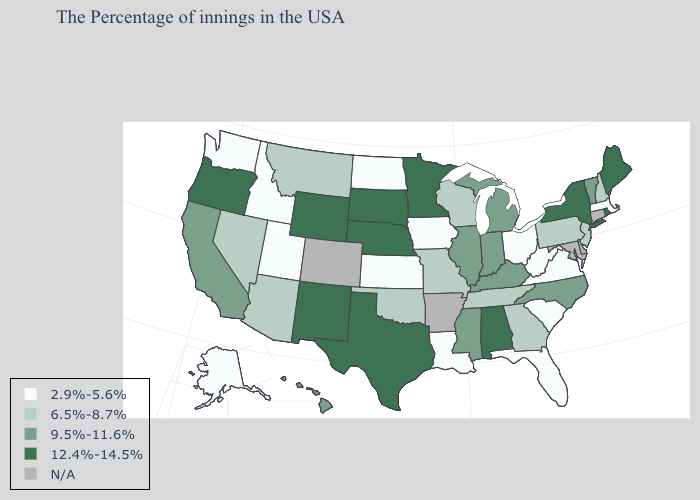Is the legend a continuous bar?
Give a very brief answer. No. Name the states that have a value in the range N/A?
Quick response, please. Connecticut, Delaware, Maryland, Arkansas, Colorado. What is the value of Kansas?
Short answer required. 2.9%-5.6%. Does the map have missing data?
Answer briefly. Yes. What is the value of Oregon?
Quick response, please. 12.4%-14.5%. Does Tennessee have the lowest value in the USA?
Give a very brief answer. No. Name the states that have a value in the range N/A?
Concise answer only. Connecticut, Delaware, Maryland, Arkansas, Colorado. How many symbols are there in the legend?
Answer briefly. 5. Name the states that have a value in the range 9.5%-11.6%?
Quick response, please. Vermont, North Carolina, Michigan, Kentucky, Indiana, Illinois, Mississippi, California, Hawaii. Name the states that have a value in the range 12.4%-14.5%?
Write a very short answer. Maine, Rhode Island, New York, Alabama, Minnesota, Nebraska, Texas, South Dakota, Wyoming, New Mexico, Oregon. Name the states that have a value in the range 2.9%-5.6%?
Answer briefly. Massachusetts, Virginia, South Carolina, West Virginia, Ohio, Florida, Louisiana, Iowa, Kansas, North Dakota, Utah, Idaho, Washington, Alaska. Which states have the lowest value in the South?
Give a very brief answer. Virginia, South Carolina, West Virginia, Florida, Louisiana. What is the value of Oklahoma?
Concise answer only. 6.5%-8.7%. What is the value of Georgia?
Keep it brief. 6.5%-8.7%. 